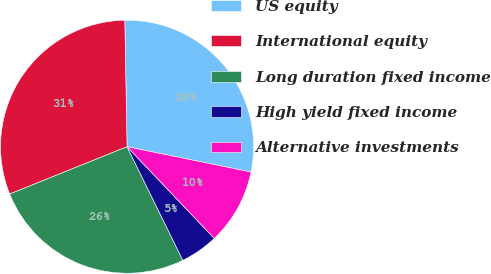<chart> <loc_0><loc_0><loc_500><loc_500><pie_chart><fcel>US equity<fcel>International equity<fcel>Long duration fixed income<fcel>High yield fixed income<fcel>Alternative investments<nl><fcel>28.49%<fcel>30.81%<fcel>26.16%<fcel>4.84%<fcel>9.69%<nl></chart> 